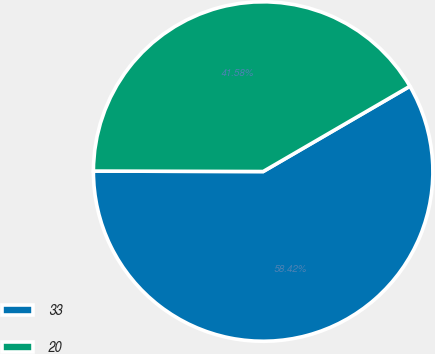Convert chart. <chart><loc_0><loc_0><loc_500><loc_500><pie_chart><fcel>33<fcel>20<nl><fcel>58.42%<fcel>41.58%<nl></chart> 